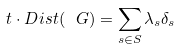<formula> <loc_0><loc_0><loc_500><loc_500>t \cdot D i s t ( \ G ) = \sum _ { s \in S } \lambda _ { s } \delta _ { s }</formula> 